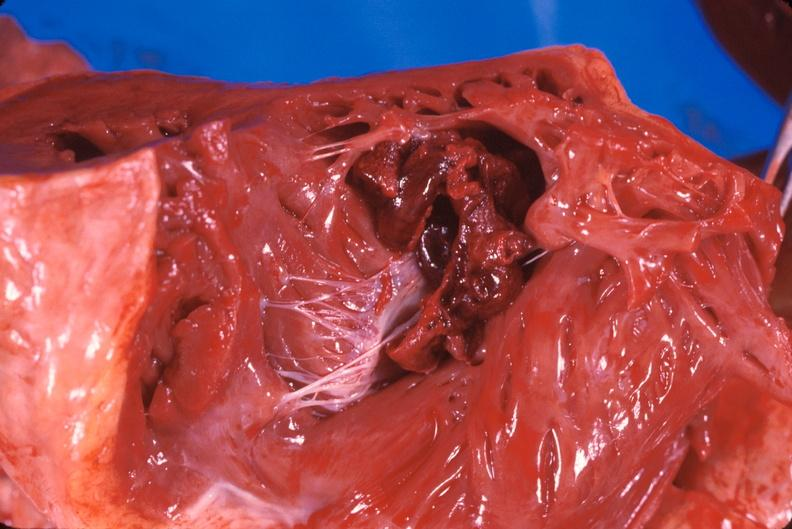does amyloidosis show thromboembolus from leg veins in right ventricle and atrium?
Answer the question using a single word or phrase. No 